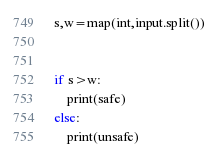Convert code to text. <code><loc_0><loc_0><loc_500><loc_500><_Python_>
s,w=map(int,input.split())


if s>w:
    print(safe)
else:
    print(unsafe)</code> 